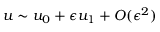<formula> <loc_0><loc_0><loc_500><loc_500>u \sim u _ { 0 } + \epsilon u _ { 1 } + O ( \epsilon ^ { 2 } )</formula> 